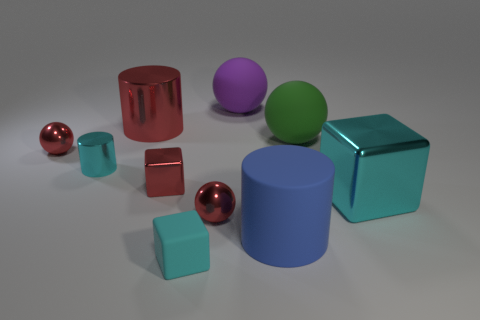How many metallic spheres are in front of the big cyan metallic block? 1 